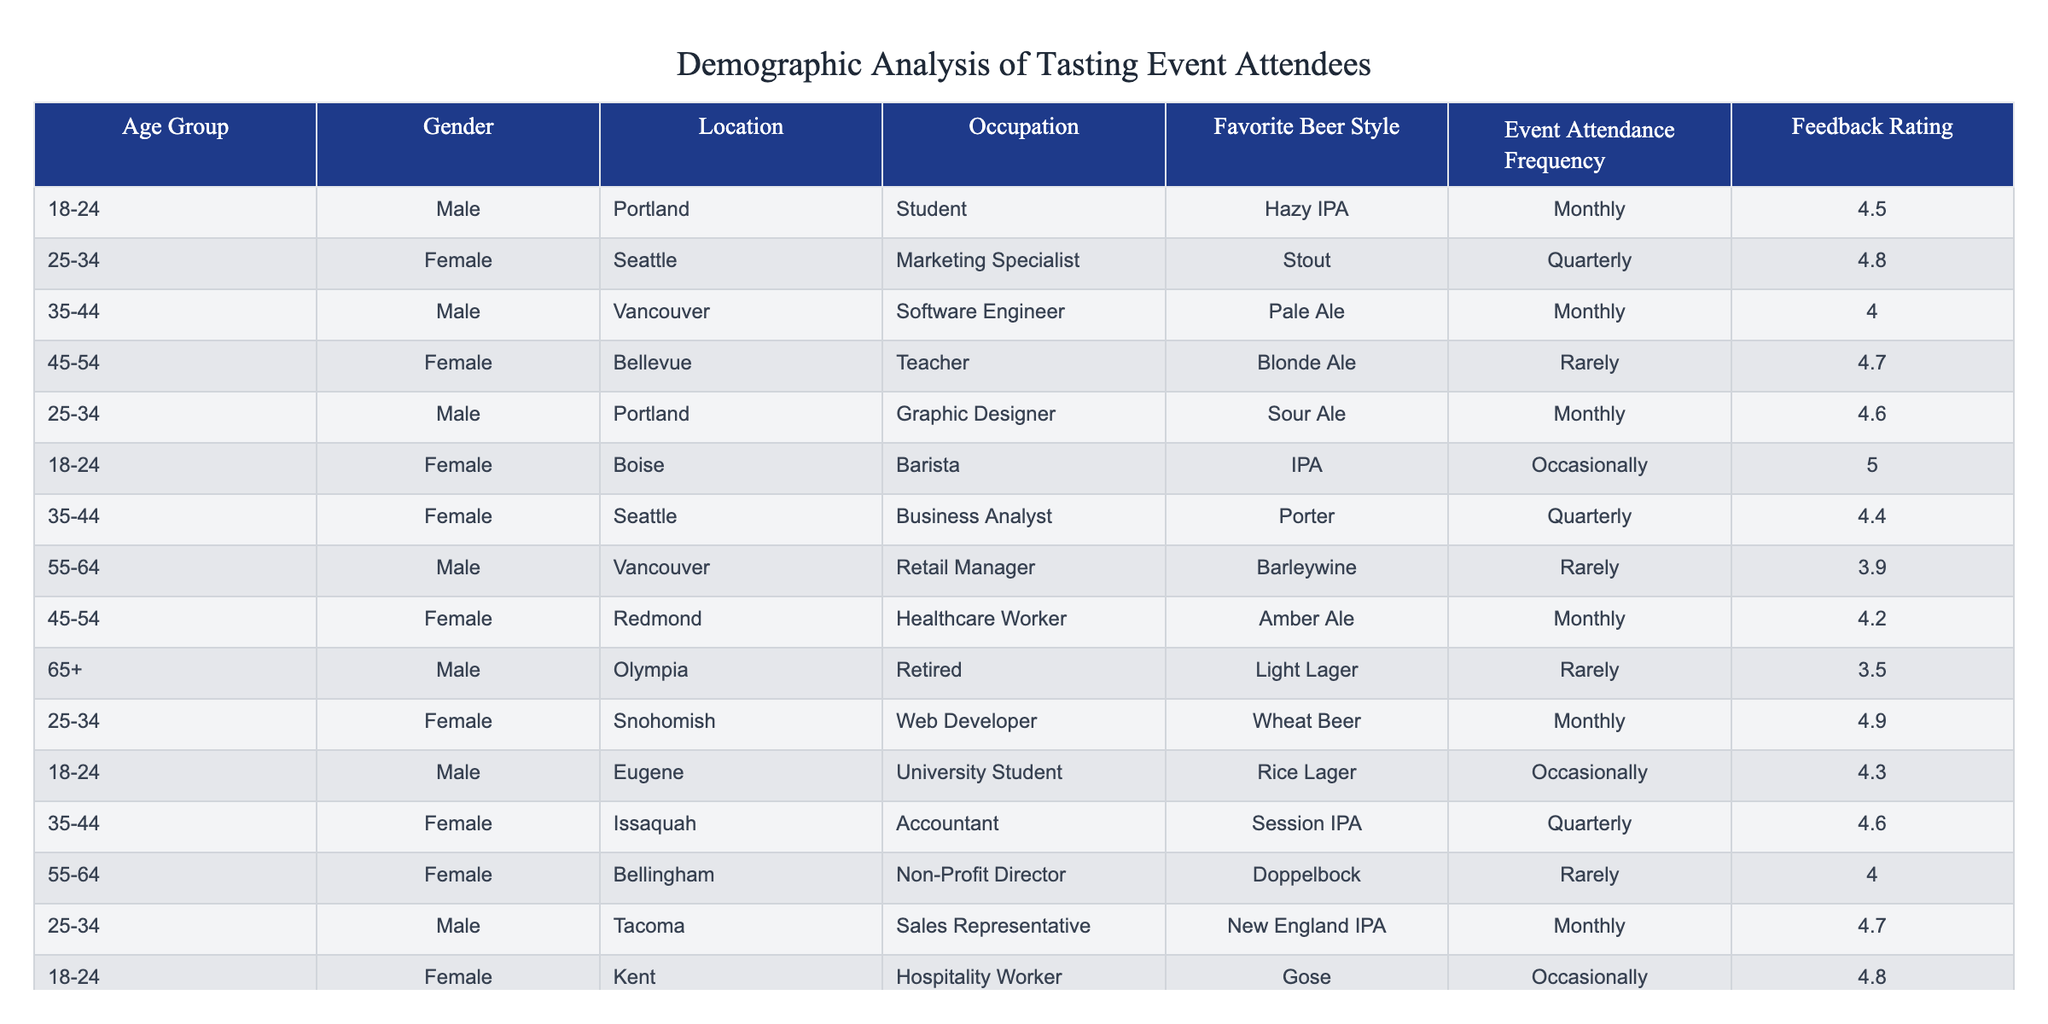What is the favorite beer style of the youngest age group? The youngest age group is 18-24, and the favorite beer style for attendees in this group includes Hazy IPA and IPA.
Answer: Hazy IPA and IPA Which gender has the highest feedback rating overall? The feedback ratings for females and males in the table are: females (4.8, 4.7, 4.4, 4.2, 4.0, 4.9, 4.8) averaging 4.57 and males (4.5, 4.0, 3.9, 3.5, 4.6, 4.7) averaging 4.40. Females have the higher average rating.
Answer: Female How many attendees attend events monthly? The attendees marked as monthly in the 'Event Attendance Frequency' column are counted: 5, giving us a total of 5 monthly attendees.
Answer: 5 What is the average feedback rating for females? The feedback ratings for females are 4.8, 4.7, 4.4, 4.2, 4.0, 4.9, and 4.8. Summing these gives 28.8 and dividing by 7 (number of respondents) gives 28.8 / 7 = 4.114, roughly 4.11.
Answer: 4.11 Is there any attendee from the location Olympia? There is one attendee from Olympia, who is 65+ years old and is a retired male.
Answer: Yes Which age group has the lowest average feedback rating? The age groups and their average ratings are: 18-24 (4.5), 25-34 (4.57), 35-44 (4.53), 45-54 (4.5), 55-64 (3.95), and 65+ (3.5). The lowest average rating comes from the 65+ age group at 3.5.
Answer: 65+ age group What is the difference in feedback ratings between males and females of the age group 35-44? The male in this age group has a feedback rating of 4.0, while the female has a feedback rating of 4.4. The difference is 4.4 - 4.0 = 0.4.
Answer: 0.4 How many different favorite beer styles are represented in the table? The unique favorite beer styles listed are Hazy IPA, Stout, Pale Ale, Blonde Ale, Sour Ale, IPA, Porter, Barleywine, Amber Ale, Light Lager, Wheat Beer, and Dopplebock, totaling 12 distinct styles.
Answer: 12 What percentage of the attendees prefer Stout as their favorite beer style? One attendee prefers Stout out of a total of 14 attendees. To calculate the percentage: (1 / 14) * 100 = 7.14%.
Answer: 7.14% What is the most common occupation among the attendees? The occupations are Student, Marketing Specialist, Software Engineer, Teacher, Graphic Designer, Barista, Business Analyst, Retail Manager, Healthcare Worker, Retired, Web Developer, Sales Representative, and Hospitality Worker. There are no repeat occupations, so the most common is simply “none.”
Answer: None (no repeats) 